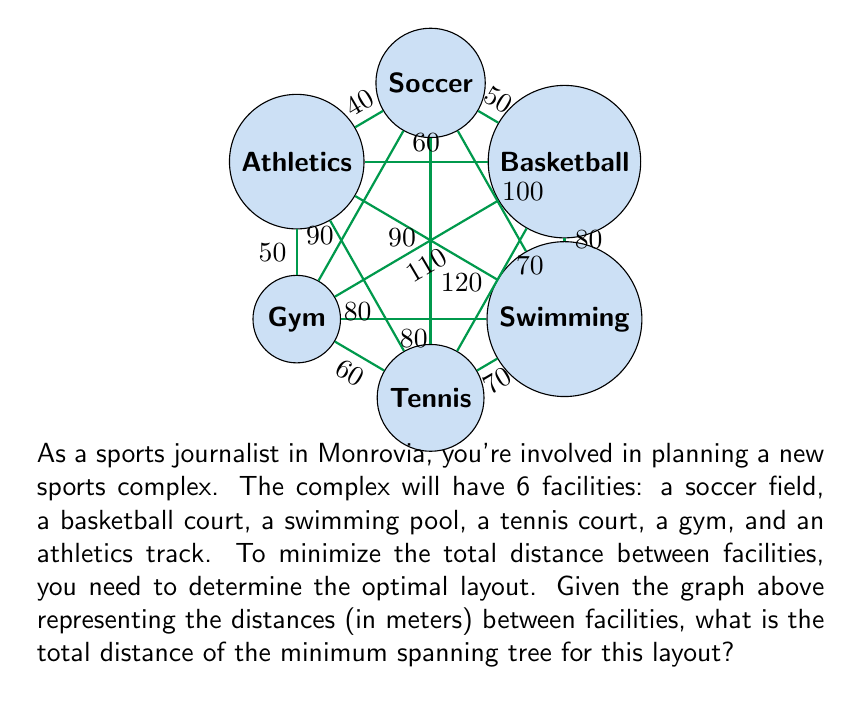Give your solution to this math problem. To find the minimum spanning tree (MST) for this graph, we'll use Kruskal's algorithm:

1) First, sort all edges by weight (distance) in ascending order:
   40 (F-A), 50 (A-B), 50 (E-F), 60 (B-F), 60 (D-E), 70 (C-D), 70 (B-D), 80 (B-C), 80 (C-E), 80 (D-F)

2) Start with an empty MST and add edges in order, skipping those that would create a cycle:

   - Add F-A (40m)
   - Add A-B (50m)
   - Add E-F (50m)
   - Skip B-F (would create cycle)
   - Add D-E (60m)
   - Add C-D (70m)

3) At this point, we have added 5 edges, which is sufficient for a MST in a graph with 6 vertices (n-1 edges where n is the number of vertices).

4) Sum the distances of the edges in the MST:
   $$ 40 + 50 + 50 + 60 + 70 = 270 $$

Therefore, the total distance of the minimum spanning tree is 270 meters.
Answer: 270 meters 